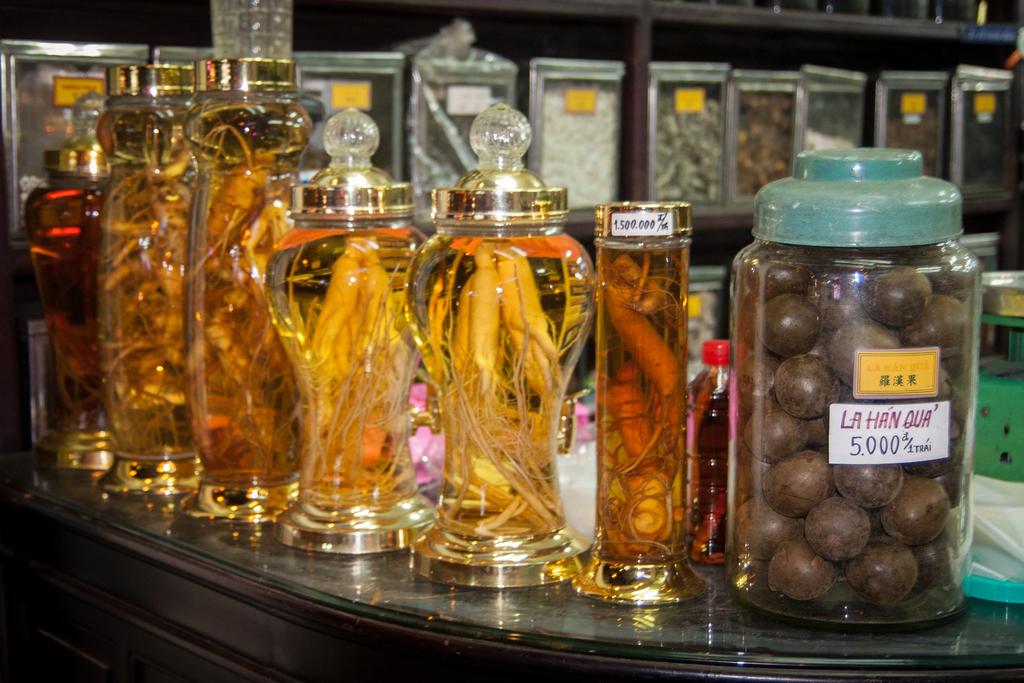What is the price of the food on the right?
Your answer should be compact. 5.000. What is in the big jar?
Your response must be concise. La han qua. 